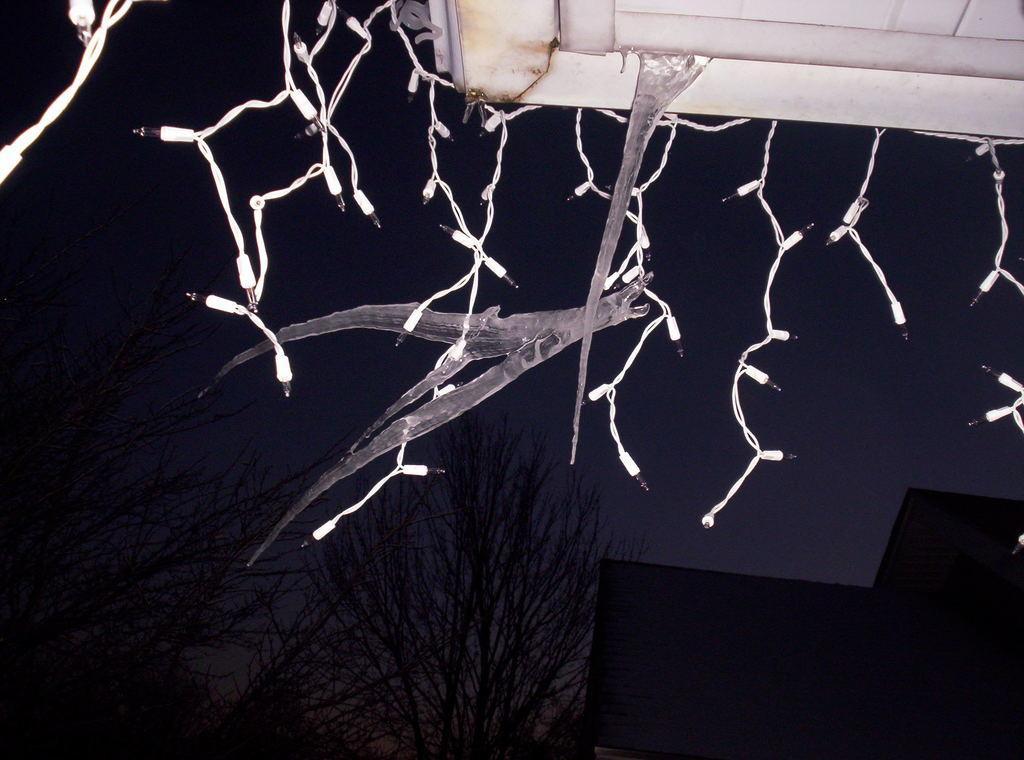In one or two sentences, can you explain what this image depicts? In this image we can see white color series lights place on the top. In the background we can see group of trees ,building and sky. 